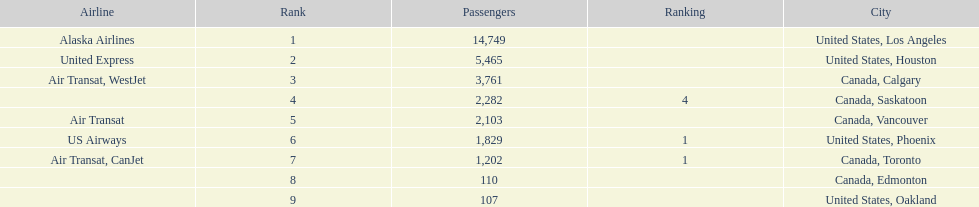Which airline carries the most passengers? Alaska Airlines. 